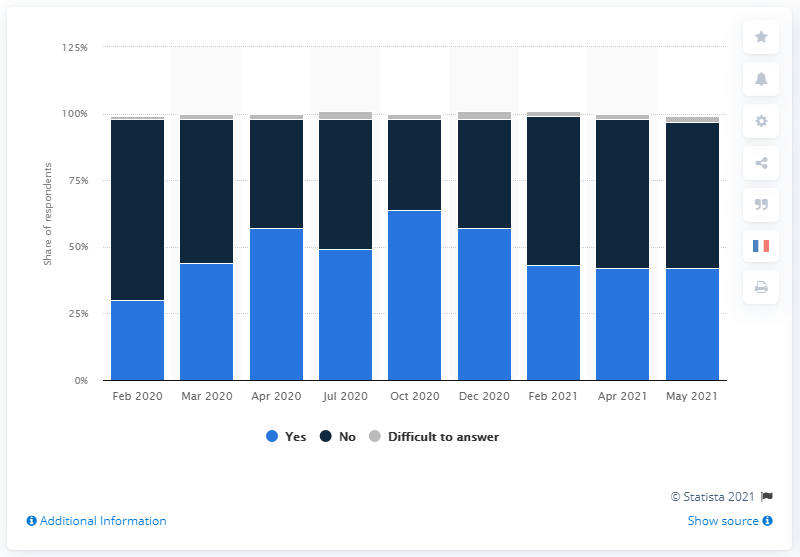Indicate a few pertinent items in this graphic. The peak fear of COVID-19 in October of 2020 was 64 percent. According to data from the previous year in April, the public was fearful of COVID-19 with a fear index of 57. 